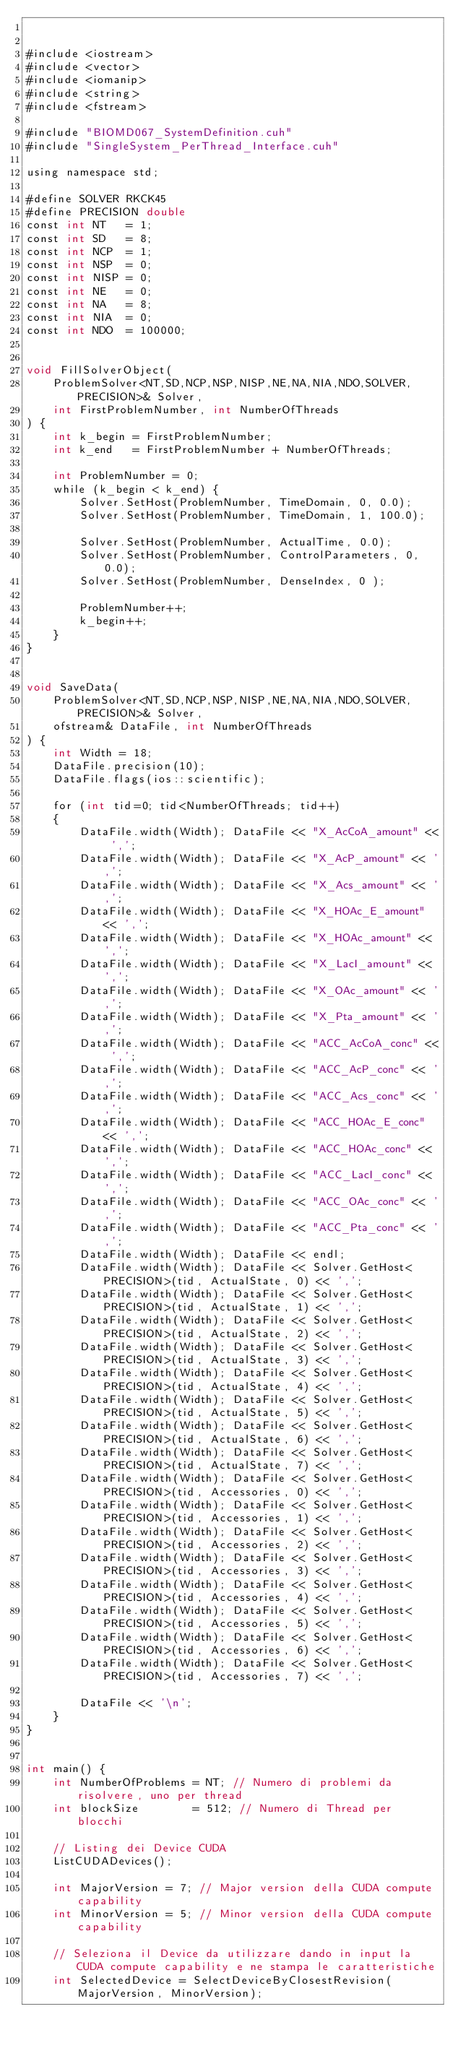<code> <loc_0><loc_0><loc_500><loc_500><_Cuda_>

#include <iostream>
#include <vector>
#include <iomanip>
#include <string>
#include <fstream>

#include "BIOMD067_SystemDefinition.cuh"
#include "SingleSystem_PerThread_Interface.cuh"

using namespace std;

#define SOLVER RKCK45
#define PRECISION double
const int NT   = 1;
const int SD   = 8;
const int NCP  = 1;
const int NSP  = 0;
const int NISP = 0;
const int NE   = 0;
const int NA   = 8;
const int NIA  = 0;
const int NDO  = 100000;


void FillSolverObject(
    ProblemSolver<NT,SD,NCP,NSP,NISP,NE,NA,NIA,NDO,SOLVER,PRECISION>& Solver, 
    int FirstProblemNumber, int NumberOfThreads
) {
    int k_begin = FirstProblemNumber;
    int k_end   = FirstProblemNumber + NumberOfThreads;
	
    int ProblemNumber = 0;
    while (k_begin < k_end) {
        Solver.SetHost(ProblemNumber, TimeDomain, 0, 0.0);
        Solver.SetHost(ProblemNumber, TimeDomain, 1, 100.0);  

        Solver.SetHost(ProblemNumber, ActualTime, 0.0);
        Solver.SetHost(ProblemNumber, ControlParameters, 0, 0.0);
        Solver.SetHost(ProblemNumber, DenseIndex, 0 );

        ProblemNumber++;
        k_begin++;
    }
}


void SaveData(
    ProblemSolver<NT,SD,NCP,NSP,NISP,NE,NA,NIA,NDO,SOLVER,PRECISION>& Solver, 
    ofstream& DataFile, int NumberOfThreads
) {
    int Width = 18;
    DataFile.precision(10);
    DataFile.flags(ios::scientific);
	
    for (int tid=0; tid<NumberOfThreads; tid++)
    {
        DataFile.width(Width); DataFile << "X_AcCoA_amount" << ',';
        DataFile.width(Width); DataFile << "X_AcP_amount" << ',';
        DataFile.width(Width); DataFile << "X_Acs_amount" << ',';
        DataFile.width(Width); DataFile << "X_HOAc_E_amount" << ',';
        DataFile.width(Width); DataFile << "X_HOAc_amount" << ',';
        DataFile.width(Width); DataFile << "X_LacI_amount" << ',';
        DataFile.width(Width); DataFile << "X_OAc_amount" << ',';
        DataFile.width(Width); DataFile << "X_Pta_amount" << ',';
        DataFile.width(Width); DataFile << "ACC_AcCoA_conc" << ',';
        DataFile.width(Width); DataFile << "ACC_AcP_conc" << ',';
        DataFile.width(Width); DataFile << "ACC_Acs_conc" << ',';
        DataFile.width(Width); DataFile << "ACC_HOAc_E_conc" << ',';
        DataFile.width(Width); DataFile << "ACC_HOAc_conc" << ',';
        DataFile.width(Width); DataFile << "ACC_LacI_conc" << ',';
        DataFile.width(Width); DataFile << "ACC_OAc_conc" << ',';
        DataFile.width(Width); DataFile << "ACC_Pta_conc" << ',';
        DataFile.width(Width); DataFile << endl;
        DataFile.width(Width); DataFile << Solver.GetHost<PRECISION>(tid, ActualState, 0) << ',';
        DataFile.width(Width); DataFile << Solver.GetHost<PRECISION>(tid, ActualState, 1) << ',';
        DataFile.width(Width); DataFile << Solver.GetHost<PRECISION>(tid, ActualState, 2) << ',';
        DataFile.width(Width); DataFile << Solver.GetHost<PRECISION>(tid, ActualState, 3) << ',';
        DataFile.width(Width); DataFile << Solver.GetHost<PRECISION>(tid, ActualState, 4) << ',';
        DataFile.width(Width); DataFile << Solver.GetHost<PRECISION>(tid, ActualState, 5) << ',';
        DataFile.width(Width); DataFile << Solver.GetHost<PRECISION>(tid, ActualState, 6) << ',';
        DataFile.width(Width); DataFile << Solver.GetHost<PRECISION>(tid, ActualState, 7) << ',';
        DataFile.width(Width); DataFile << Solver.GetHost<PRECISION>(tid, Accessories, 0) << ',';
        DataFile.width(Width); DataFile << Solver.GetHost<PRECISION>(tid, Accessories, 1) << ',';
        DataFile.width(Width); DataFile << Solver.GetHost<PRECISION>(tid, Accessories, 2) << ',';
        DataFile.width(Width); DataFile << Solver.GetHost<PRECISION>(tid, Accessories, 3) << ',';
        DataFile.width(Width); DataFile << Solver.GetHost<PRECISION>(tid, Accessories, 4) << ',';
        DataFile.width(Width); DataFile << Solver.GetHost<PRECISION>(tid, Accessories, 5) << ',';
        DataFile.width(Width); DataFile << Solver.GetHost<PRECISION>(tid, Accessories, 6) << ',';
        DataFile.width(Width); DataFile << Solver.GetHost<PRECISION>(tid, Accessories, 7) << ',';

        DataFile << '\n';
    }
}


int main() {
    int NumberOfProblems = NT; // Numero di problemi da risolvere, uno per thread
    int blockSize        = 512; // Numero di Thread per blocchi
    
    // Listing dei Device CUDA
    ListCUDADevices();

    int MajorVersion = 7; // Major version della CUDA compute capability
    int MinorVersion = 5; // Minor version della CUDA compute capability

    // Seleziona il Device da utilizzare dando in input la CUDA compute capability e ne stampa le caratteristiche
    int SelectedDevice = SelectDeviceByClosestRevision(MajorVersion, MinorVersion);</code> 